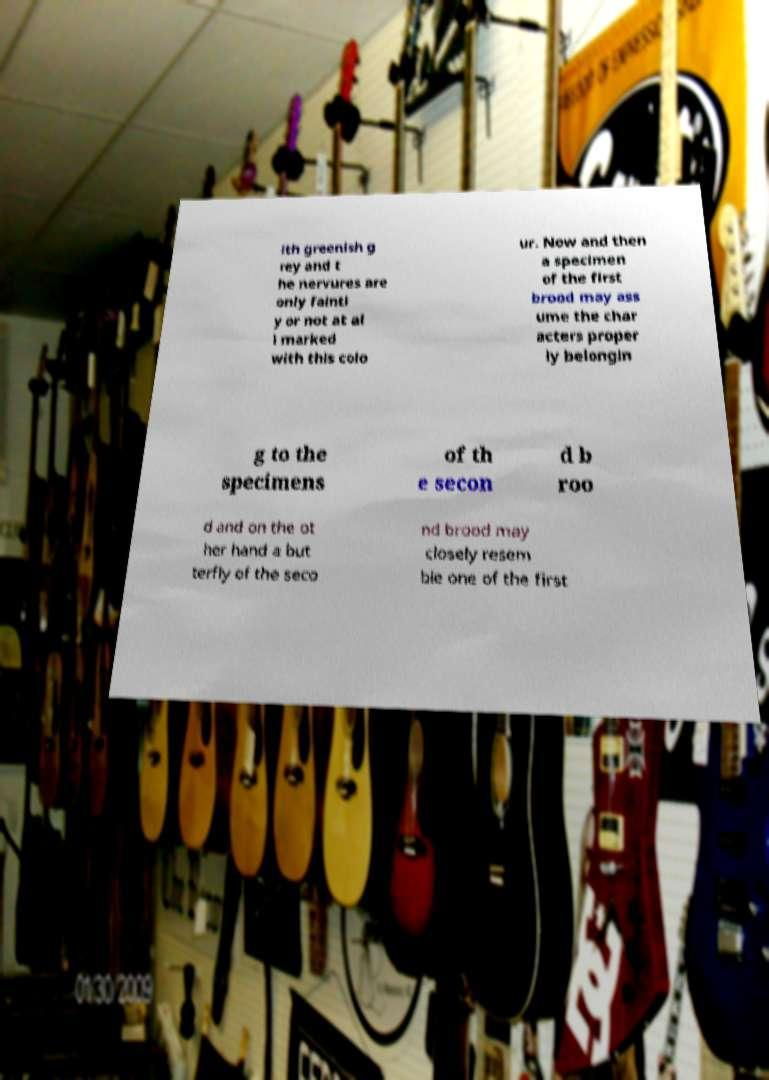What messages or text are displayed in this image? I need them in a readable, typed format. ith greenish g rey and t he nervures are only faintl y or not at al l marked with this colo ur. Now and then a specimen of the first brood may ass ume the char acters proper ly belongin g to the specimens of th e secon d b roo d and on the ot her hand a but terfly of the seco nd brood may closely resem ble one of the first 